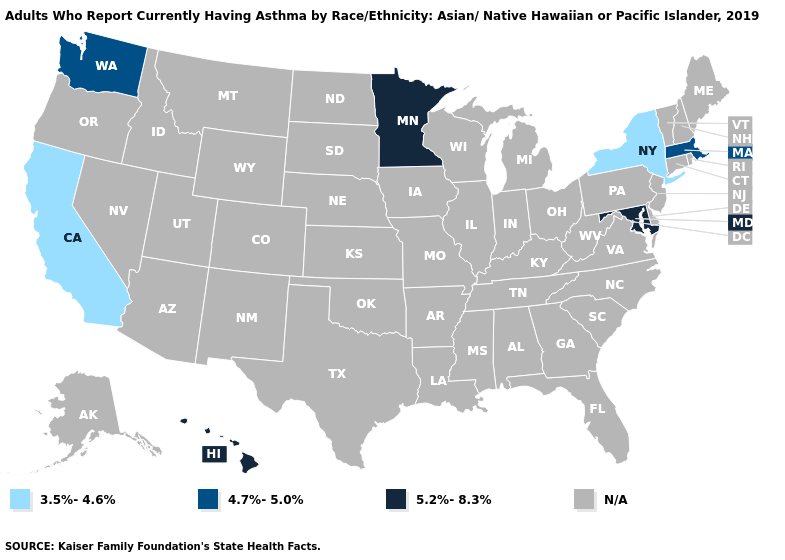Which states have the highest value in the USA?
Give a very brief answer. Hawaii, Maryland, Minnesota. Name the states that have a value in the range 3.5%-4.6%?
Quick response, please. California, New York. What is the value of Virginia?
Give a very brief answer. N/A. Does California have the lowest value in the USA?
Be succinct. Yes. Which states have the highest value in the USA?
Be succinct. Hawaii, Maryland, Minnesota. What is the value of New Jersey?
Answer briefly. N/A. What is the highest value in states that border Nevada?
Concise answer only. 3.5%-4.6%. What is the value of Missouri?
Answer briefly. N/A. What is the value of Alabama?
Quick response, please. N/A. Does California have the lowest value in the USA?
Concise answer only. Yes. What is the value of Georgia?
Quick response, please. N/A. 